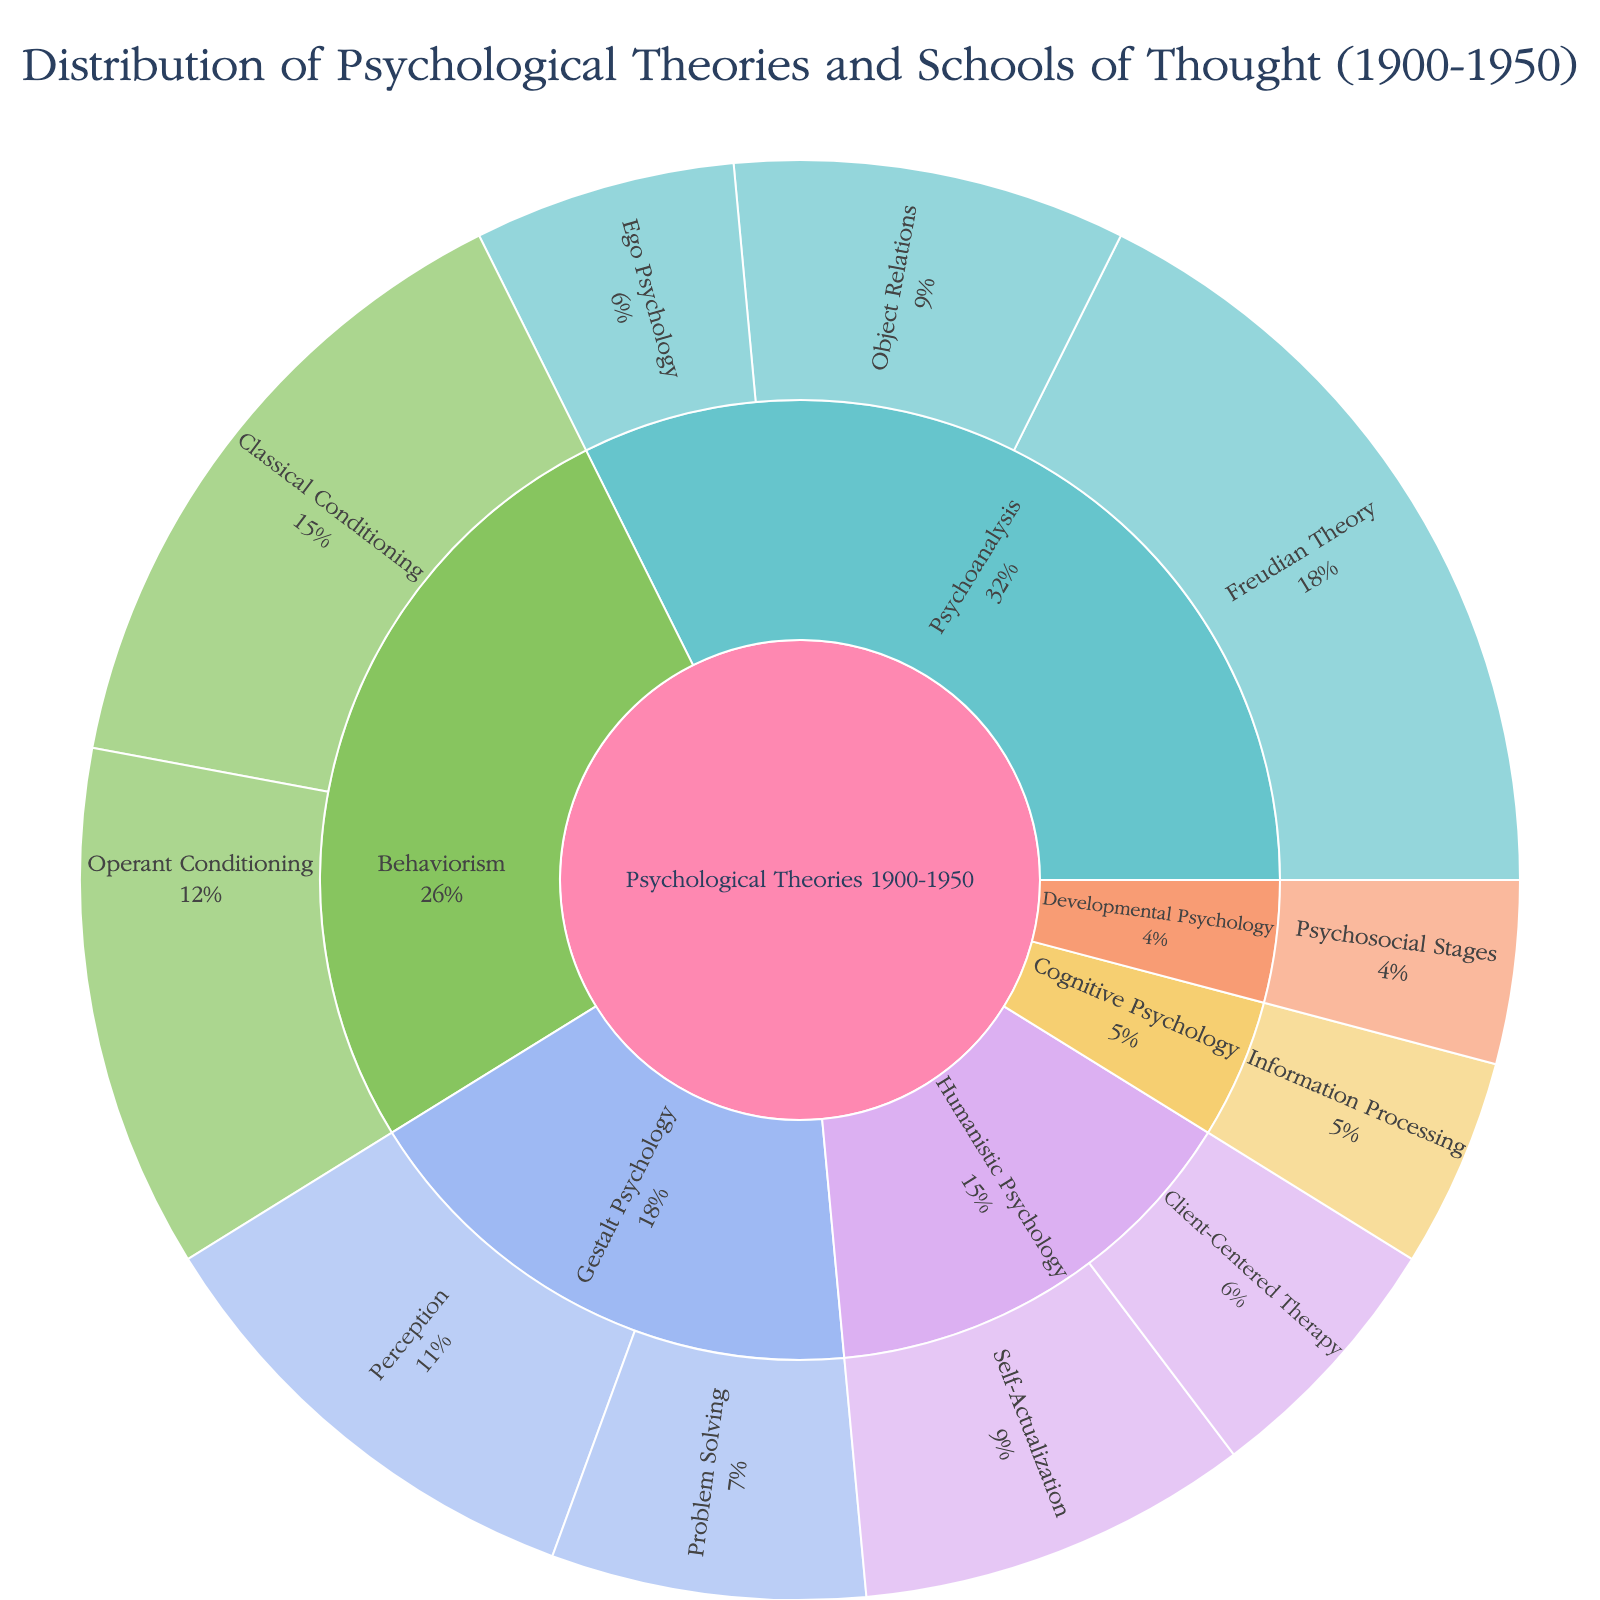What's the most represented psychological theory? The largest segment in the sunburst plot represents Psychoanalysis, showing it is the most represented.
Answer: Psychoanalysis How many schools of Psychoanalysis are depicted in the plot? The plot shows three segments under the "Psychoanalysis" section: Freudian Theory, Object Relations, and Ego Psychology.
Answer: Three Which theory has the least representation in the plot? The smallest inner segment in the plot is Developmental Psychology, specifically the "Psychosocial Stages" with a value of 7.
Answer: Developmental Psychology What's the total value for all Behaviorism theories combined? The values for Behaviorism are Classical Conditioning (25) and Operant Conditioning (20). Summing them gives 25 + 20 = 45.
Answer: 45 Which psychological theory focused on Self-Actualization during this period? The segment for Self-Actualization falls under the "Humanistic Psychology" category.
Answer: Humanistic Psychology How does the representation of Gestalt Psychology in Perception compare to Problem Solving? Perception has a value of 18, while Problem Solving has a value of 12. Thus, Perception is represented more.
Answer: Perception is greater What's the difference in representation between Freudian Theory and Ego Psychology? Freudian Theory has a value of 30 and Ego Psychology has a value of 10. Calculating the difference gives 30 - 10 = 20.
Answer: 20 Which school of thought has the highest representation in the Humanistic Psychology category? The "Self-Actualization" segment in the Humanistic Psychology category has a value of 15, whereas Client-Centered Therapy has a value of 10.
Answer: Self-Actualization What's the combined representation value for all schools in Cognitive and Developmental Psychology? Summing the values for Cognitive Psychology (8) and Developmental Psychology (7) results in 8 + 7 = 15.
Answer: 15 Which segment represents the smallest value among Psychoanalysis theories? The smallest segment under Psychoanalysis is Ego Psychology with a value of 10.
Answer: Ego Psychology 